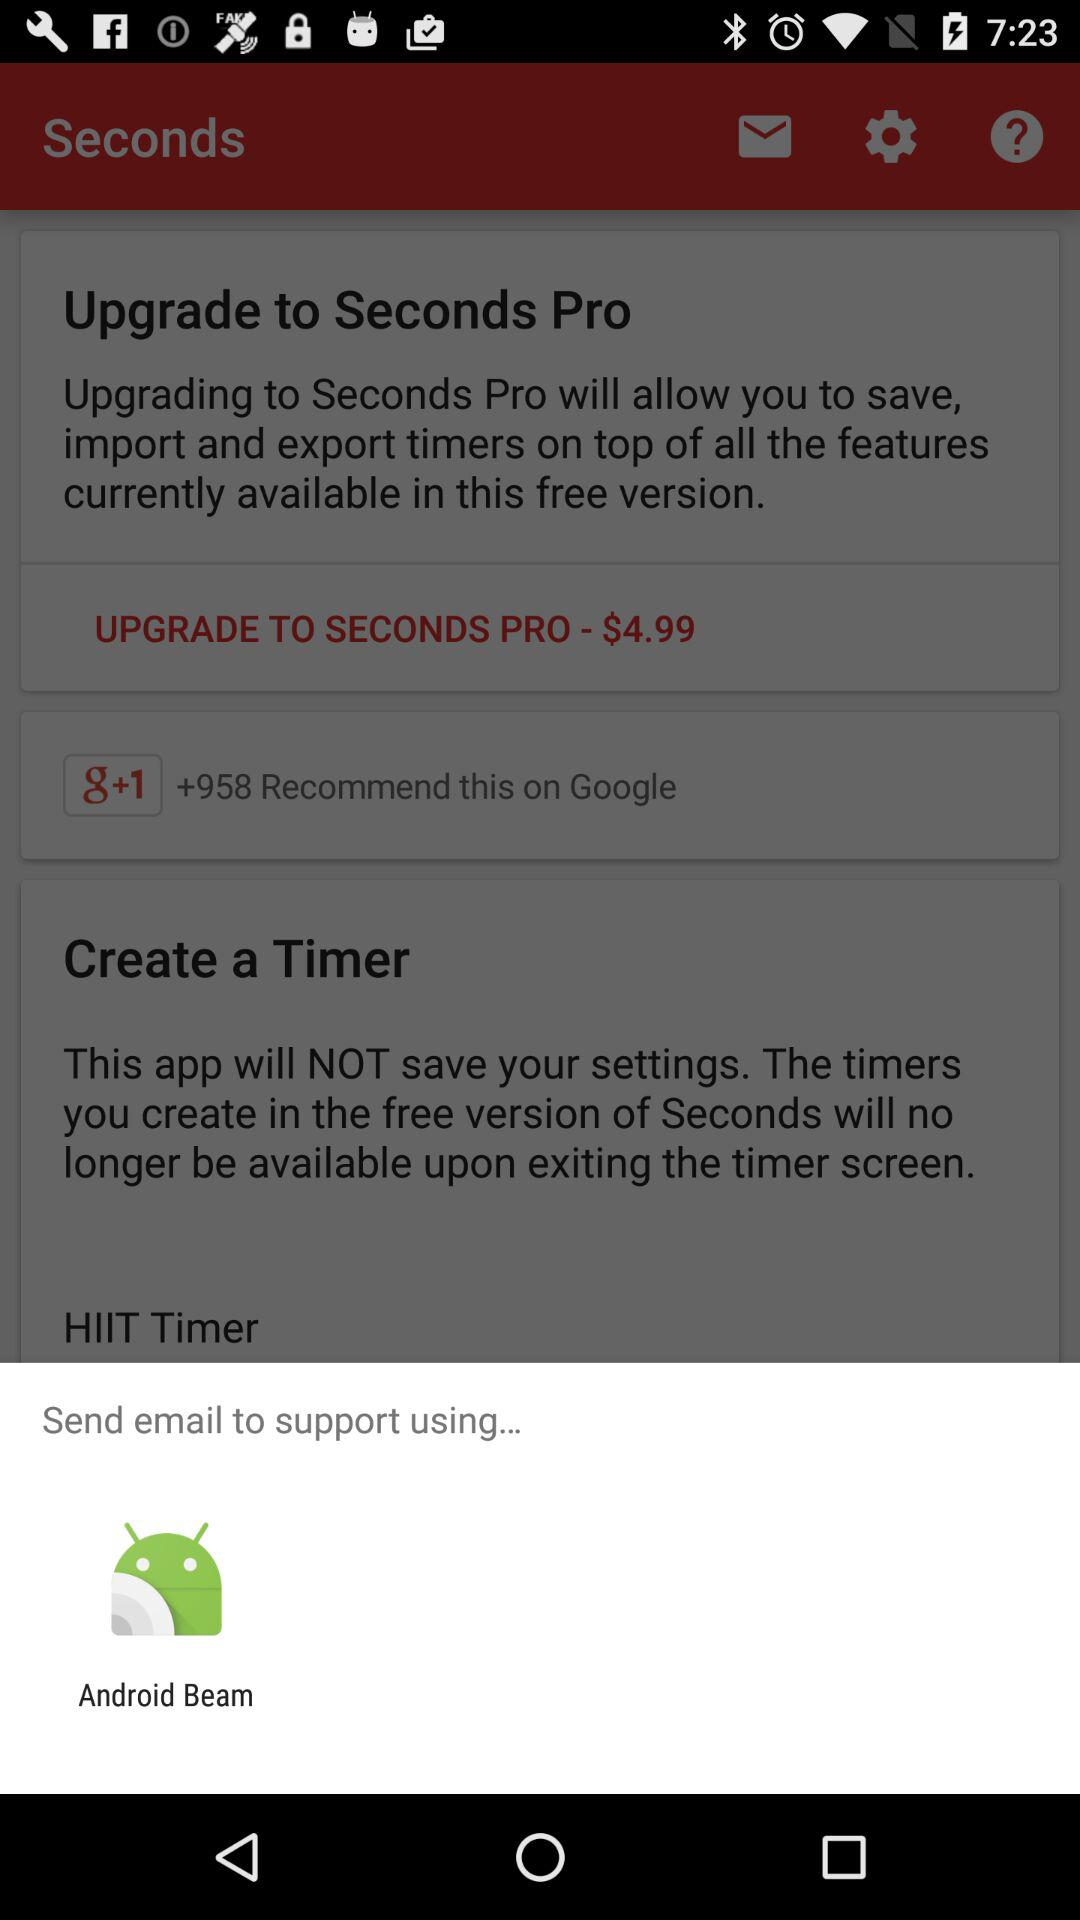What is the currency of the price? The currency is dollars. 